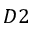<formula> <loc_0><loc_0><loc_500><loc_500>D 2</formula> 